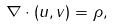Convert formula to latex. <formula><loc_0><loc_0><loc_500><loc_500>\nabla \cdot ( u , v ) = \rho ,</formula> 